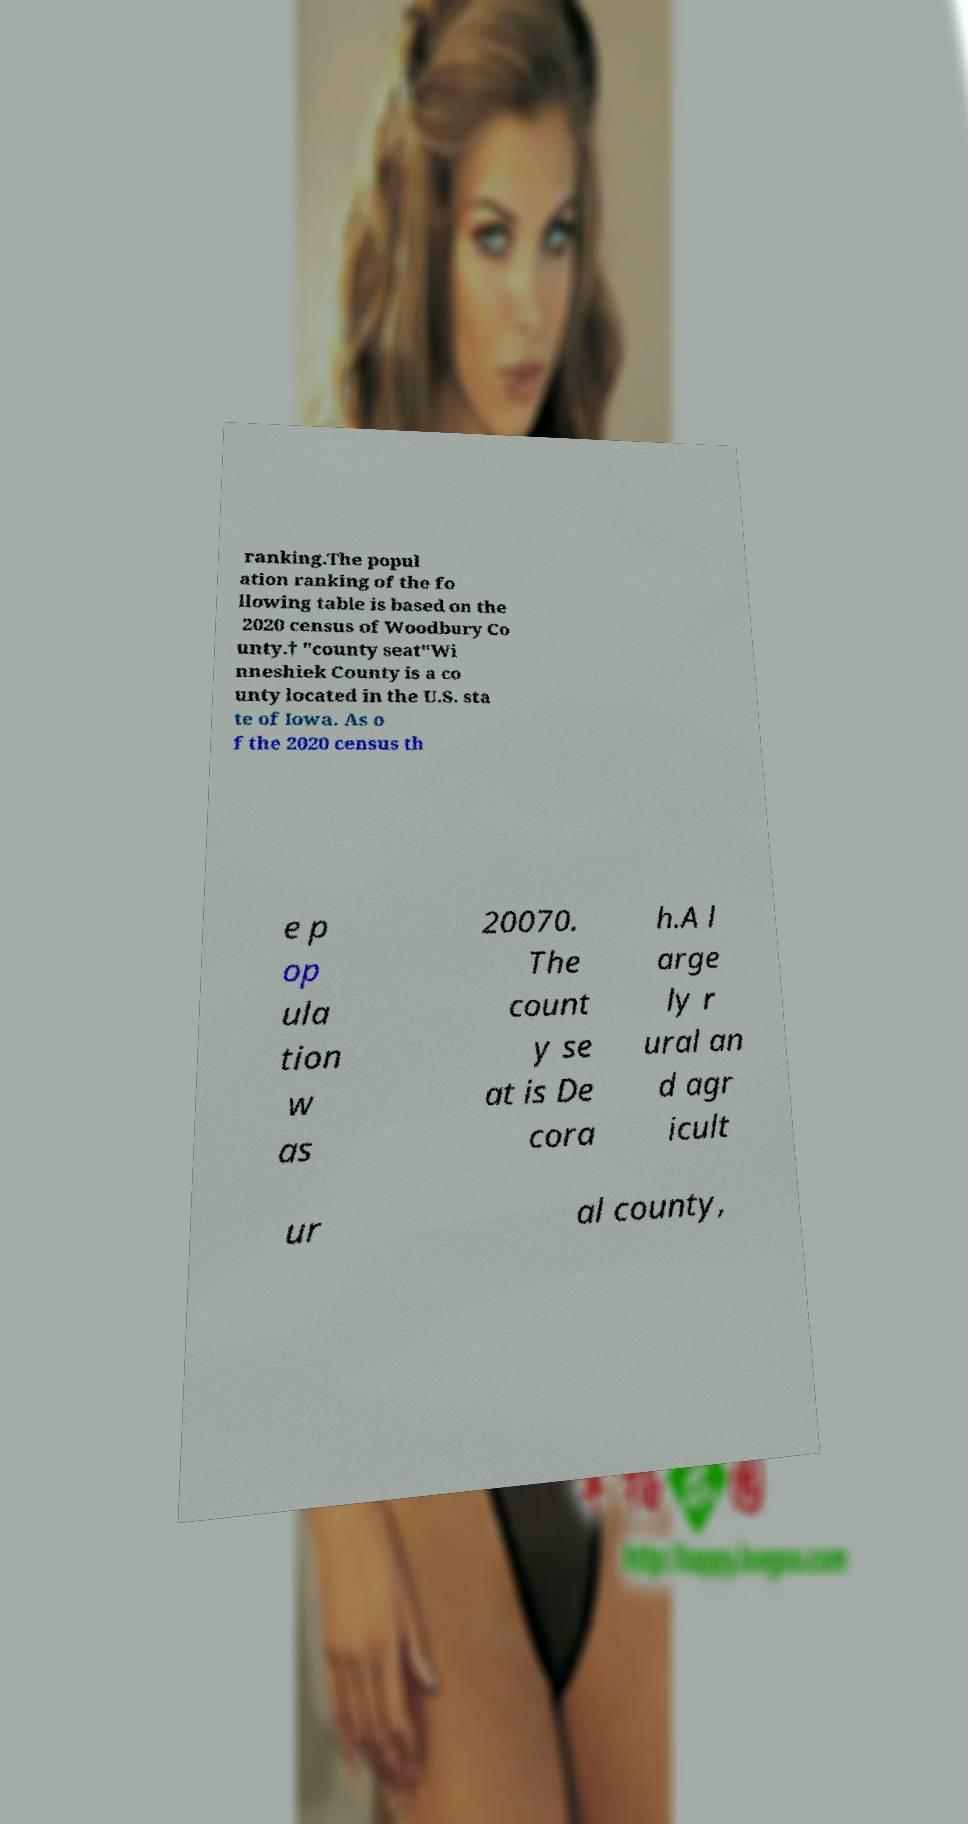Can you accurately transcribe the text from the provided image for me? ranking.The popul ation ranking of the fo llowing table is based on the 2020 census of Woodbury Co unty.† "county seat"Wi nneshiek County is a co unty located in the U.S. sta te of Iowa. As o f the 2020 census th e p op ula tion w as 20070. The count y se at is De cora h.A l arge ly r ural an d agr icult ur al county, 